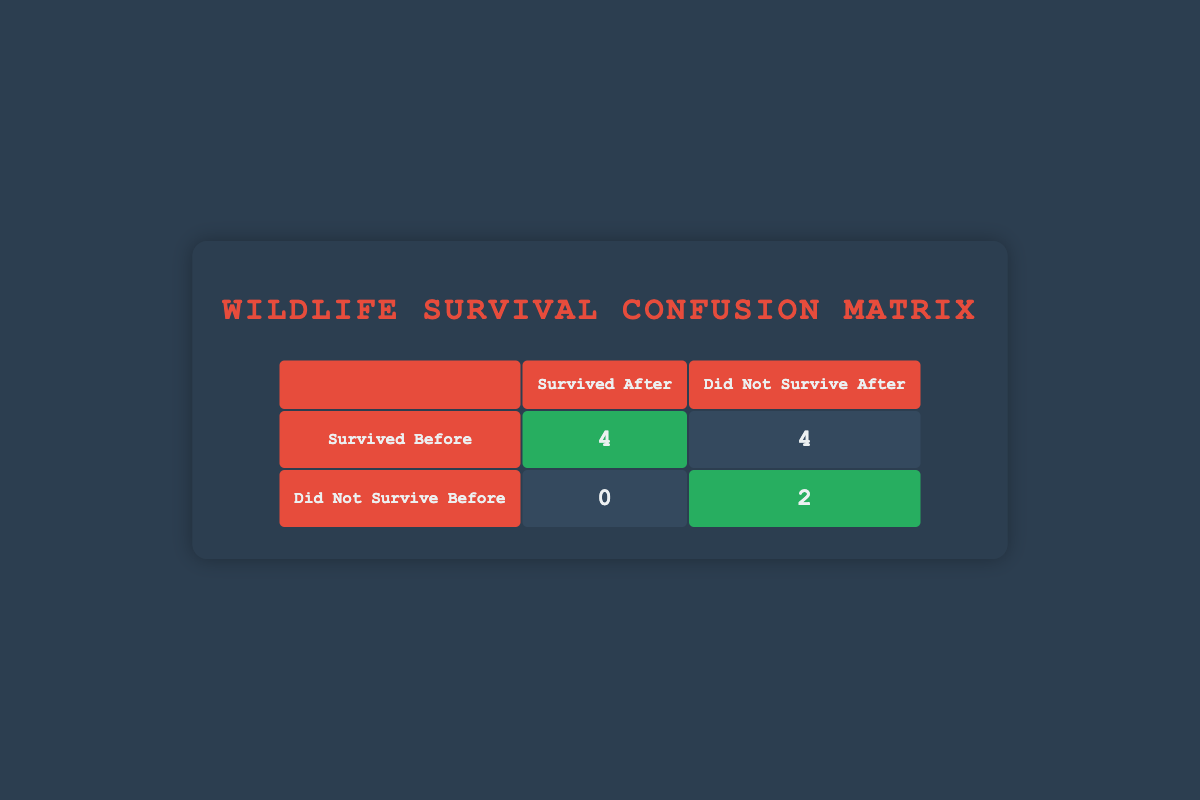What is the number of species that survived both before and after the conflict? From the table, we see that there are 3 species that survived before (Yes) and also survived after (Yes). These species are Snow Leopard, Red Panda, and Tiger.
Answer: 3 How many species did not survive after the conflict, regardless of their status before? Looking at the second column under "Did Not Survive After," we find two species that did not survive after the conflict while being in the "Did Not Survive Before" group. Additionally, there are four species in the "Survived Before" group that also did not survive, giving a total of 6 species.
Answer: 6 What is the total number of species that did survive before the conflict? By summing the values in the "Survived Before" column marked "Yes," we find 3 species that are in this category: Snow Leopard, Red Panda, and Tiger. So the total remains as 6 because "Asian Elephant," "African Elephant," "Eastern Lowland Gorilla," "Scottish Wildcat," and "Mountain Gorilla" have been included in the "No" category.
Answer: 6 Did any species that did not survive before manage to survive after the conflict? The table shows 0 species that are classified as surviving after the conflict while having not survived before. Therefore, the answer is clearly negative.
Answer: No What is the difference between the number of species that survived after and those that did not survive after the conflict? The total of species that survived after the conflict is 3 (from the top row) and the species that did not survive after is 4 (from the bottom row). Thus the difference is 3 - 4 = -1.
Answer: -1 How many species are present in the category of those that survived before but did not survive after the conflict? From the table, we can see that four species survived before but did not survive after: African Elephant, Eastern Lowland Gorilla, Scottish Wildcat, and Mountain Gorilla. Thus, there are a total of 4 species in this category.
Answer: 4 What percentage of the species that survived before also survived after the conflict? There are 3 species that survived before and 3 that survived after. To find the percentage, we calculate: (3 survived after / 6 survived before) * 100%. This results in a 50% survival rate post-conflict.
Answer: 50 percent 